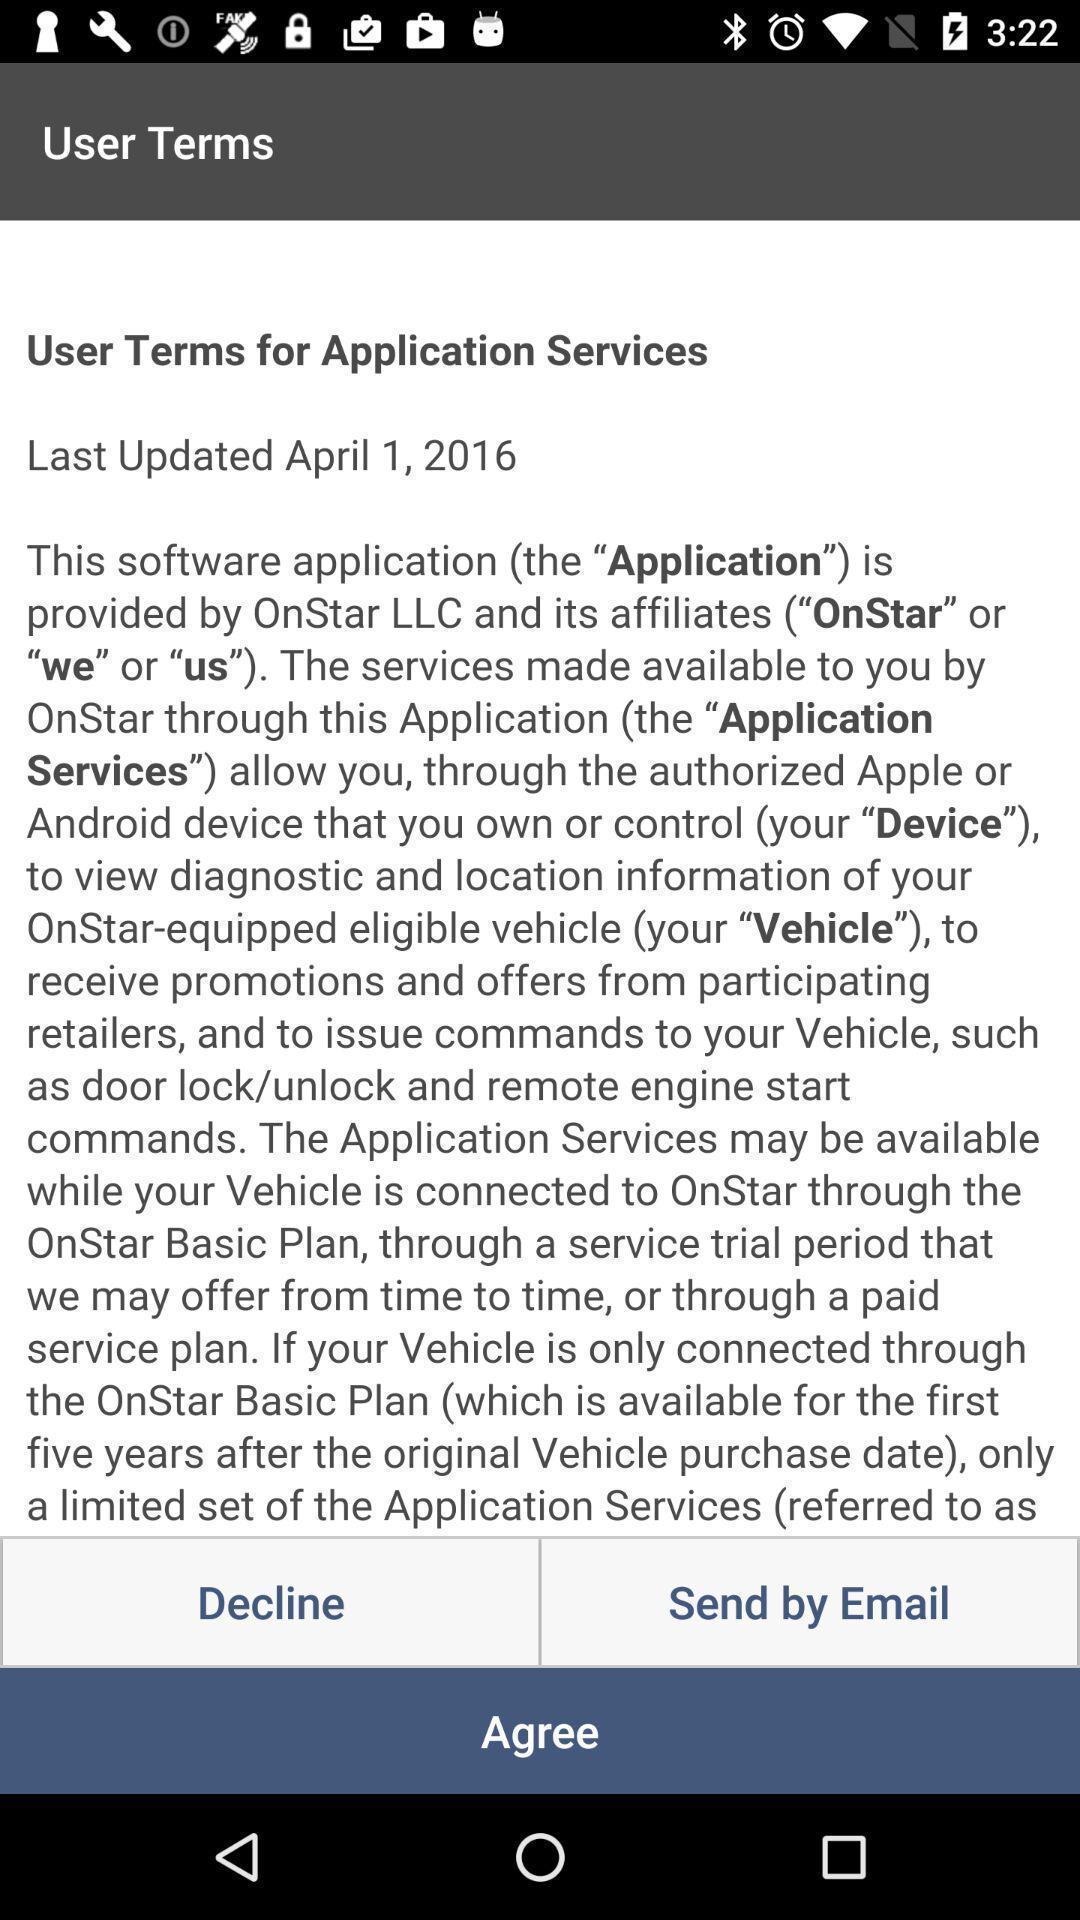Give me a narrative description of this picture. Screen showing user terms. 